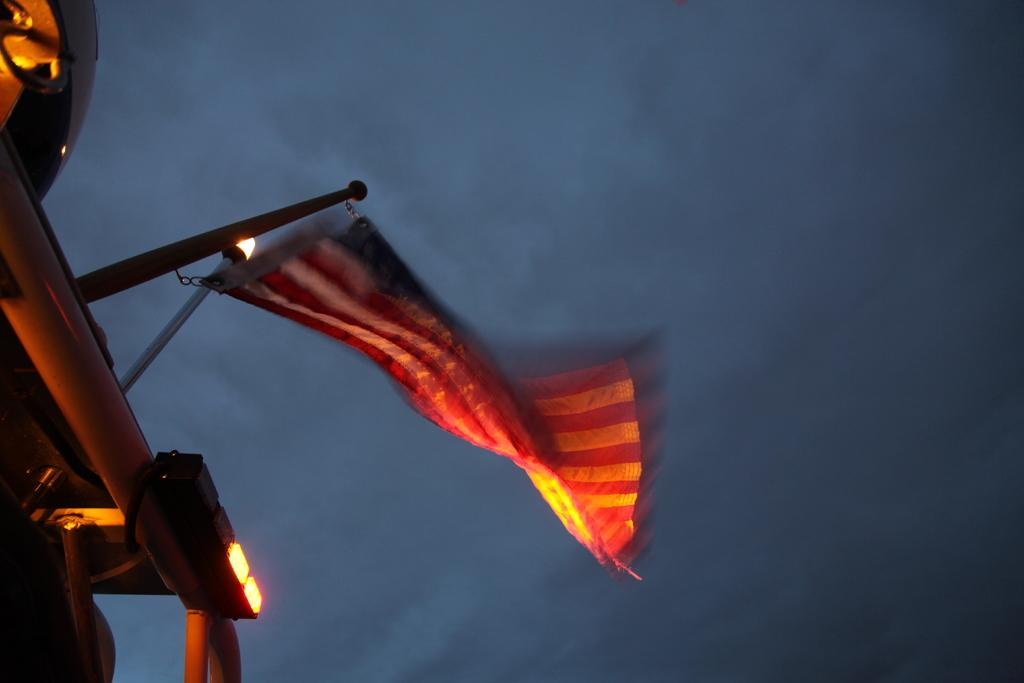What is located in the foreground of the image? There is a flag and a light on a vehicle in the foreground of the image. Can you describe the light on the vehicle? The light on the vehicle is visible in the foreground of the image. What can be seen in the background of the image? The sky is visible in the background of the image. What type of coil can be seen in the image? There is no coil present in the image. Can you hear the sound of a ball bouncing in the image? There is no sound or ball present in the image, as it is a still image. 